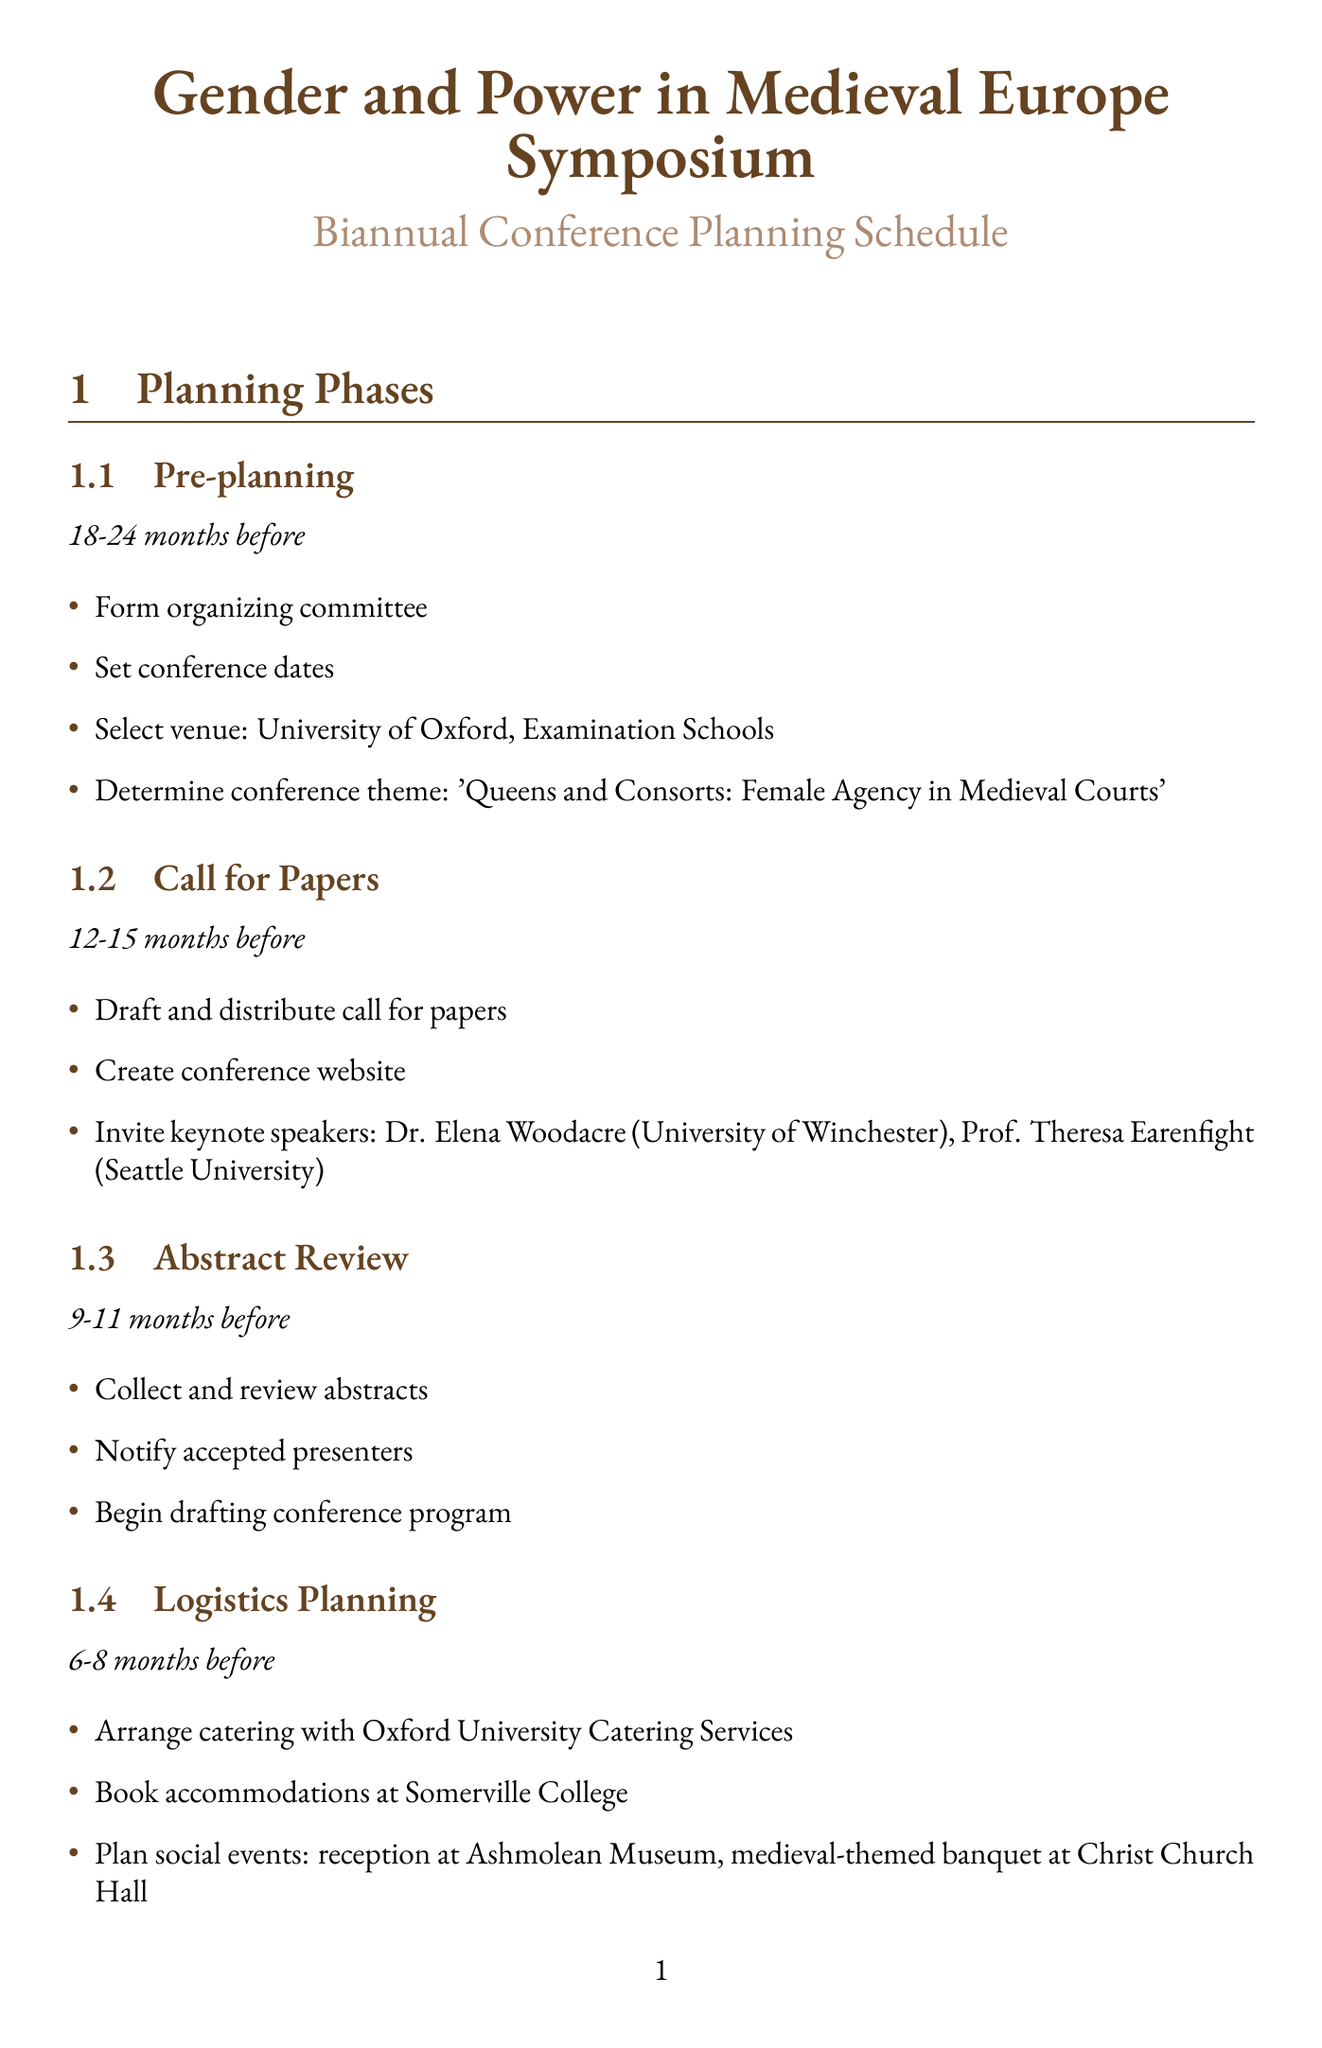what is the theme of the conference? The theme is determined in the pre-planning phase, which is 'Queens and Consorts: Female Agency in Medieval Courts'.
Answer: 'Queens and Consorts: Female Agency in Medieval Courts' who is the keynote speaker from the University of Winchester? The document lists Dr. Elena Woodacre as a keynote speaker from the University of Winchester.
Answer: Dr. Elena Woodacre how many months before does registration open? The registration opens 3-5 months before the conference.
Answer: 3-5 months what venue is selected for the conference? The venue for the conference is specified as the University of Oxford, Examination Schools.
Answer: University of Oxford, Examination Schools who organizes the special session about Gender and Power in the Icelandic Sagas? The organizer for this special session is given in the document as Prof. Jóhanna Katrín Friðriksdóttir from the University of Oslo.
Answer: Prof. Jóhanna Katrín Friðriksdóttir what is one of the social events planned for the conference? The document mentions a medieval-themed banquet at Christ Church Hall as one of the planned social events.
Answer: medieval-themed banquet at Christ Church Hall how many workshops are listed in the document? The document lists two workshops.
Answer: two which publishing house is arranging for the publication of proceedings? The proceedings publication is arranged with Boydell & Brewer as mentioned in the registration phase.
Answer: Boydell & Brewer what is the timeframe for the Abstract Review phase? The timeframe for this phase is stated as 9-11 months before the conference.
Answer: 9-11 months 